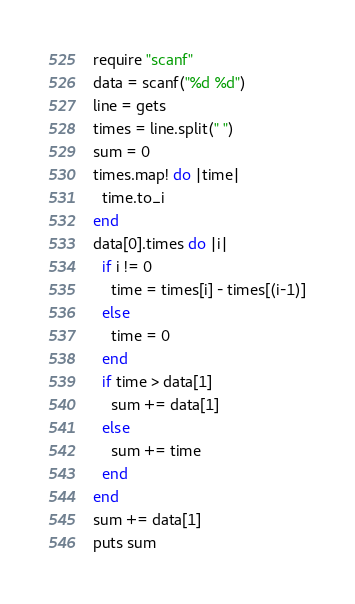<code> <loc_0><loc_0><loc_500><loc_500><_Ruby_>require "scanf"
data = scanf("%d %d")
line = gets
times = line.split(" ")
sum = 0
times.map! do |time|
  time.to_i
end
data[0].times do |i|
  if i != 0
    time = times[i] - times[(i-1)]
  else
    time = 0
  end
  if time > data[1]
    sum += data[1]
  else
    sum += time
  end
end
sum += data[1]
puts sum</code> 